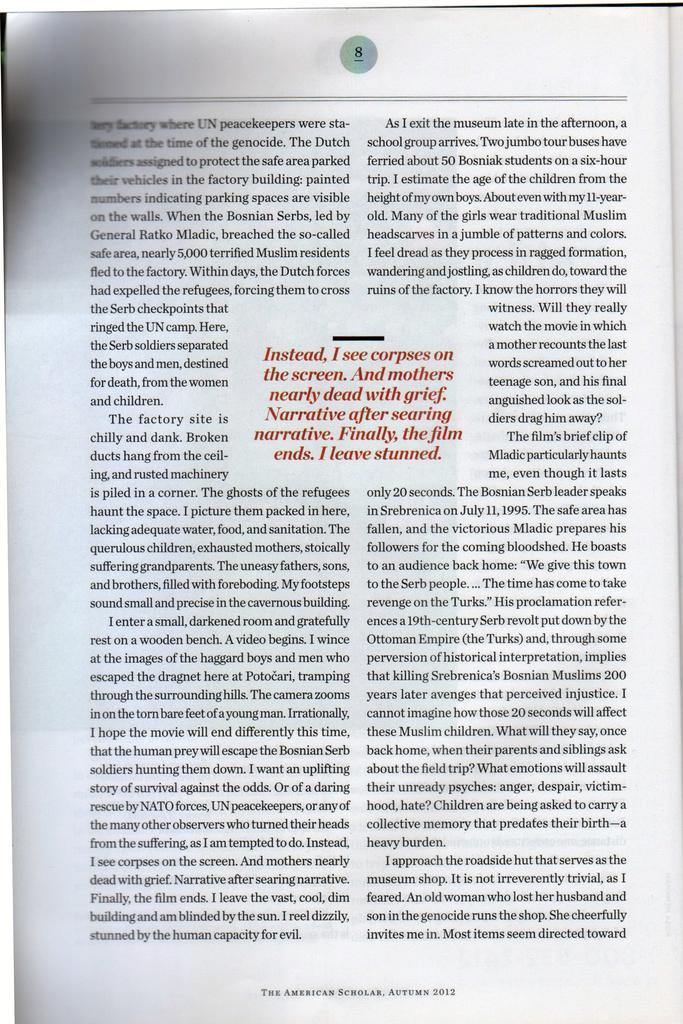Can you describe this image briefly? In the picture we can see a paper which is white in color with some information on it and the page number is 8 mentioned at the top of the information. 